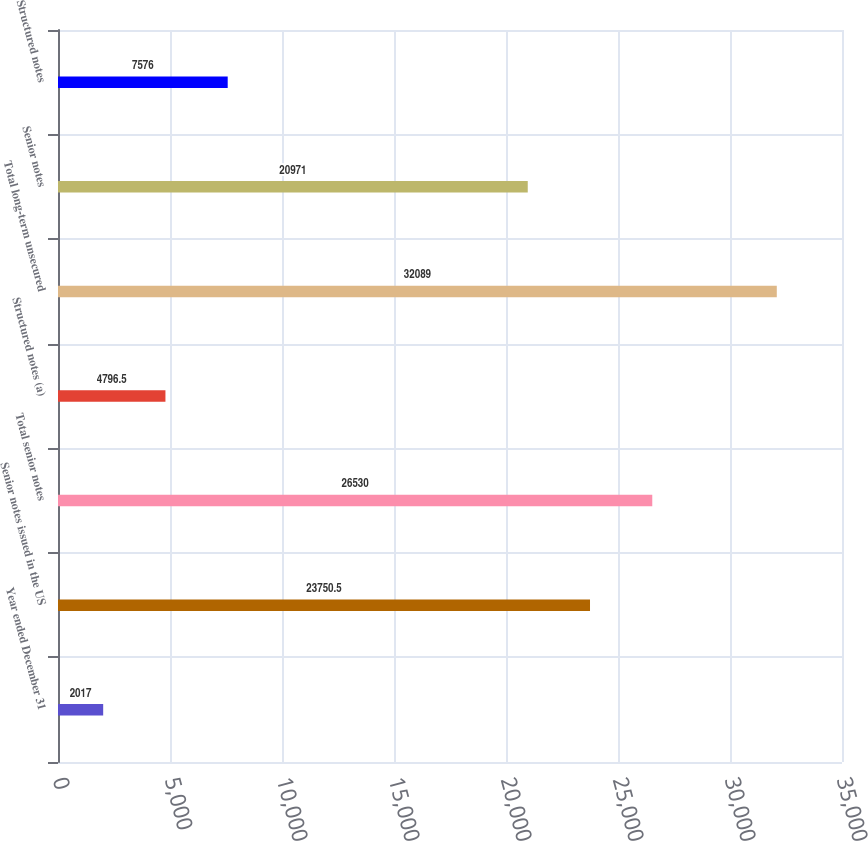<chart> <loc_0><loc_0><loc_500><loc_500><bar_chart><fcel>Year ended December 31<fcel>Senior notes issued in the US<fcel>Total senior notes<fcel>Structured notes (a)<fcel>Total long-term unsecured<fcel>Senior notes<fcel>Structured notes<nl><fcel>2017<fcel>23750.5<fcel>26530<fcel>4796.5<fcel>32089<fcel>20971<fcel>7576<nl></chart> 